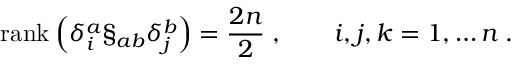Convert formula to latex. <formula><loc_0><loc_0><loc_500><loc_500>r a n k \, \left ( \delta _ { i } ^ { a } \S _ { a b } \delta _ { j } ^ { b } \right ) = \frac { 2 n } { 2 } \, , \quad i , j , k = 1 , \dots n \, .</formula> 